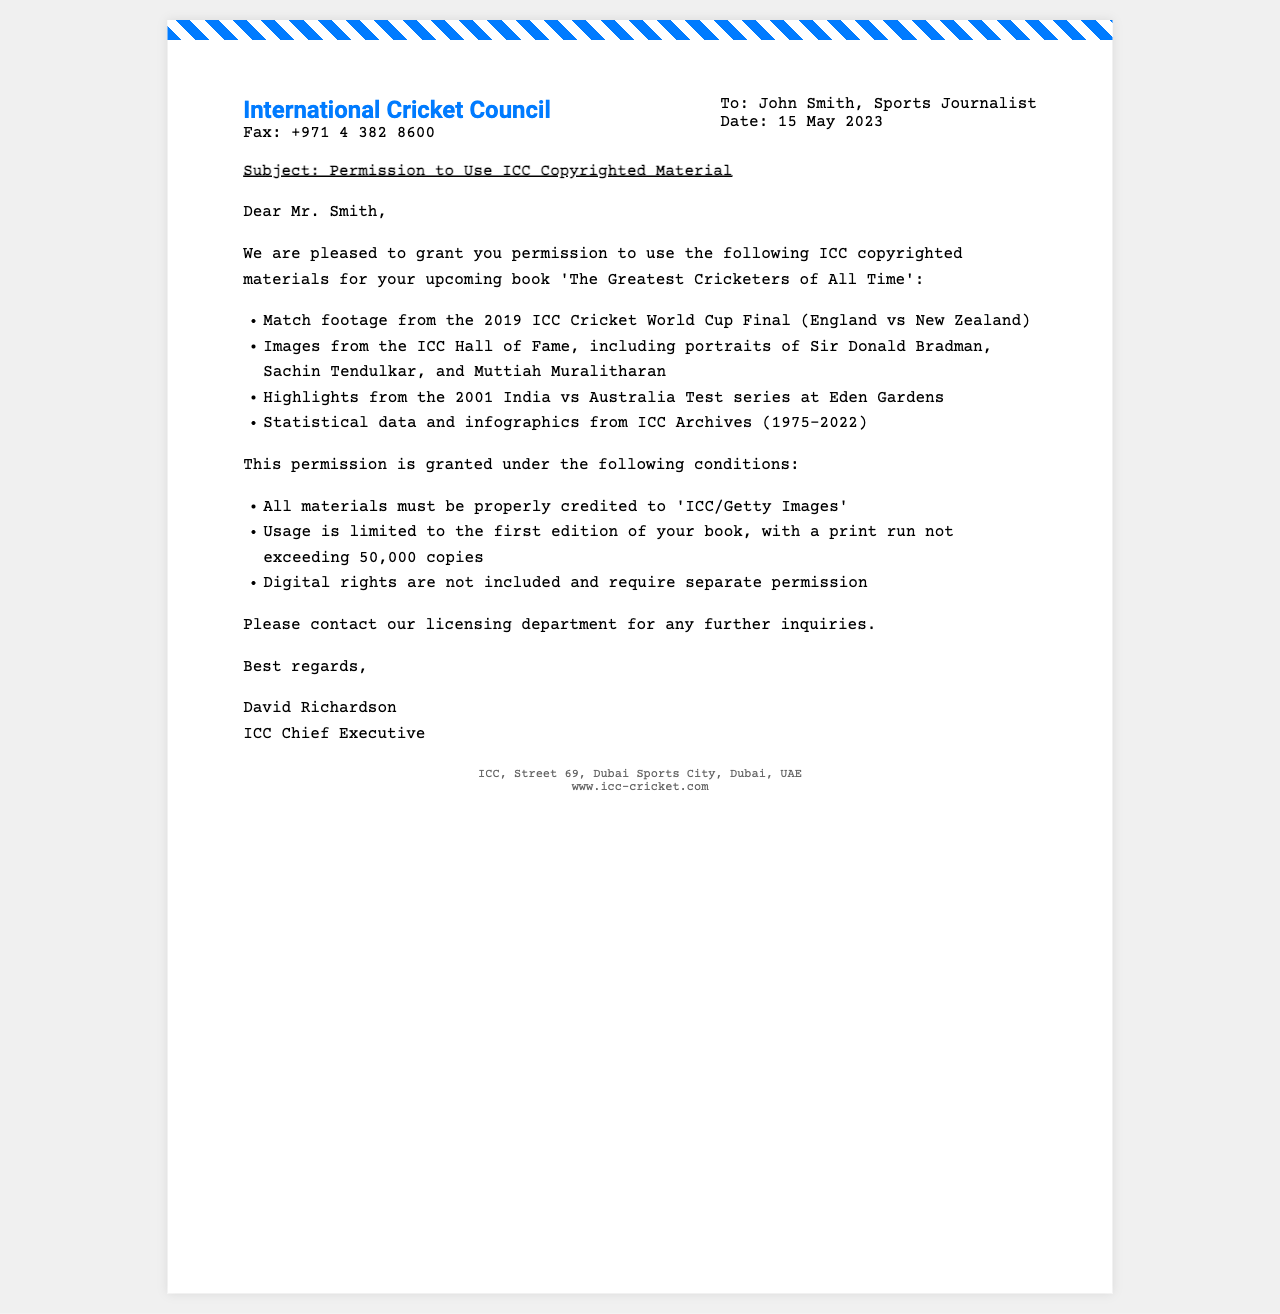What is the fax date? The date mentioned in the document is the day the fax was sent out, which is 15 May 2023.
Answer: 15 May 2023 Who is the recipient of the fax? The fax is addressed to John Smith, indicating he is the recipient.
Answer: John Smith Which ICC event's footage is included? The document specifies that match footage from the 2019 ICC Cricket World Cup Final is among the materials permitted for use.
Answer: 2019 ICC Cricket World Cup Final What is the maximum print run allowed for the book? The document states that the usage is limited to a print run not exceeding 50,000 copies.
Answer: 50,000 copies Who signed the fax? The document lists David Richardson as the signatory, thus he is the one who signed it.
Answer: David Richardson What type of permission is granted? The fax conveys permission to use certain copyrighted materials specifically for John's book.
Answer: Permission to Use Copyrighted Material What entity issued the permission? The permission is granted by the International Cricket Council, as stated at the top of the document.
Answer: International Cricket Council What is excluded from the permission granted? The document mentions that digital rights are not included in this permission and require separate permission.
Answer: Digital rights 